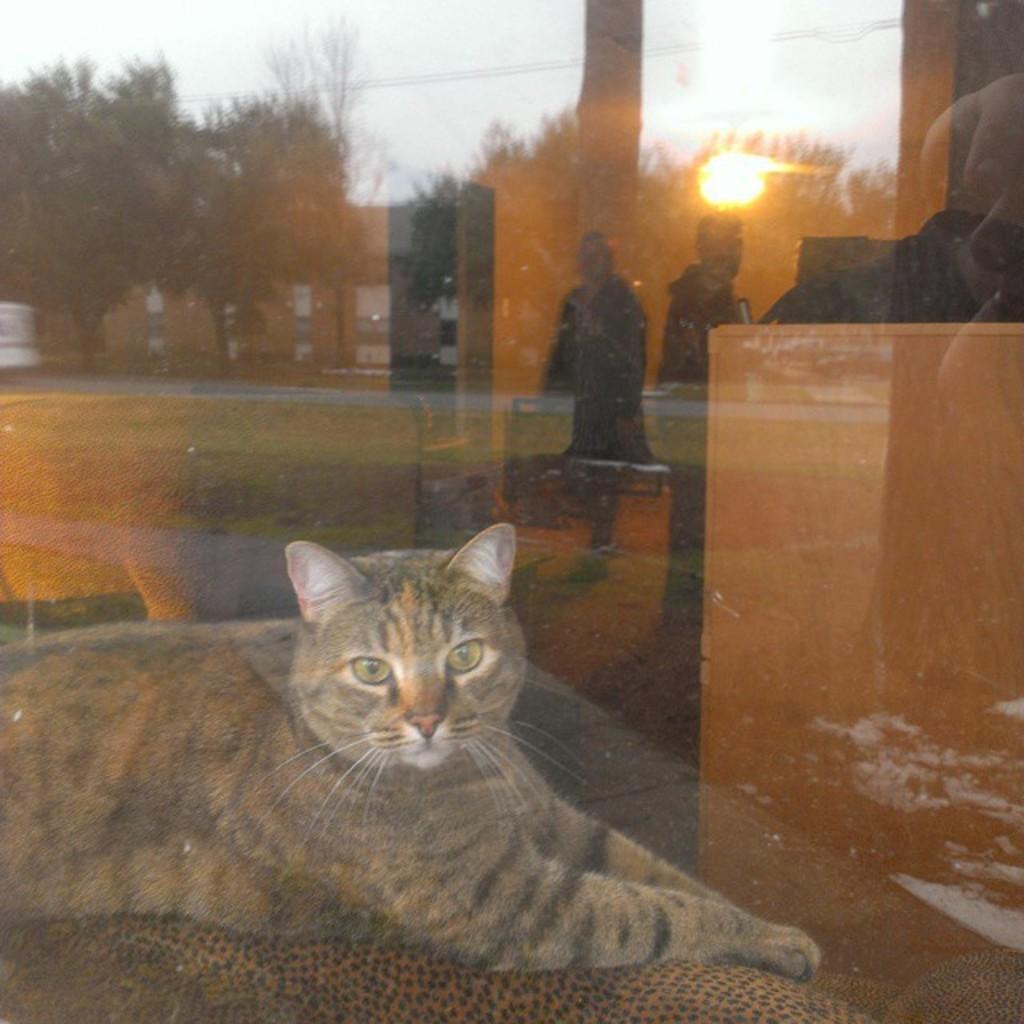Describe this image in one or two sentences. This is a cat sitting. This looks like a glass door. I can see the reflection of the trees, buildings and two people standing. Here is the grass. This is the sun in the sky. 